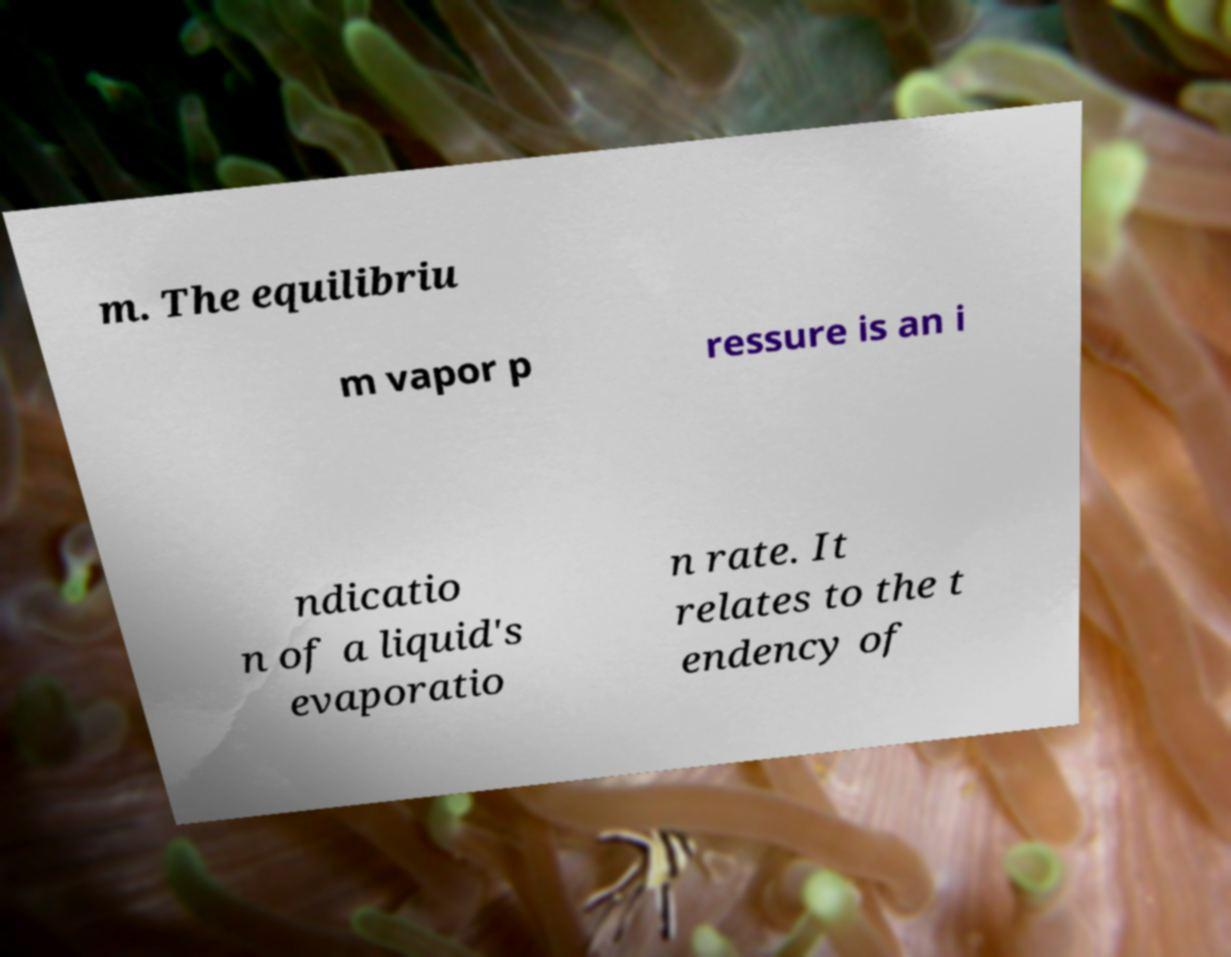Can you read and provide the text displayed in the image?This photo seems to have some interesting text. Can you extract and type it out for me? m. The equilibriu m vapor p ressure is an i ndicatio n of a liquid's evaporatio n rate. It relates to the t endency of 